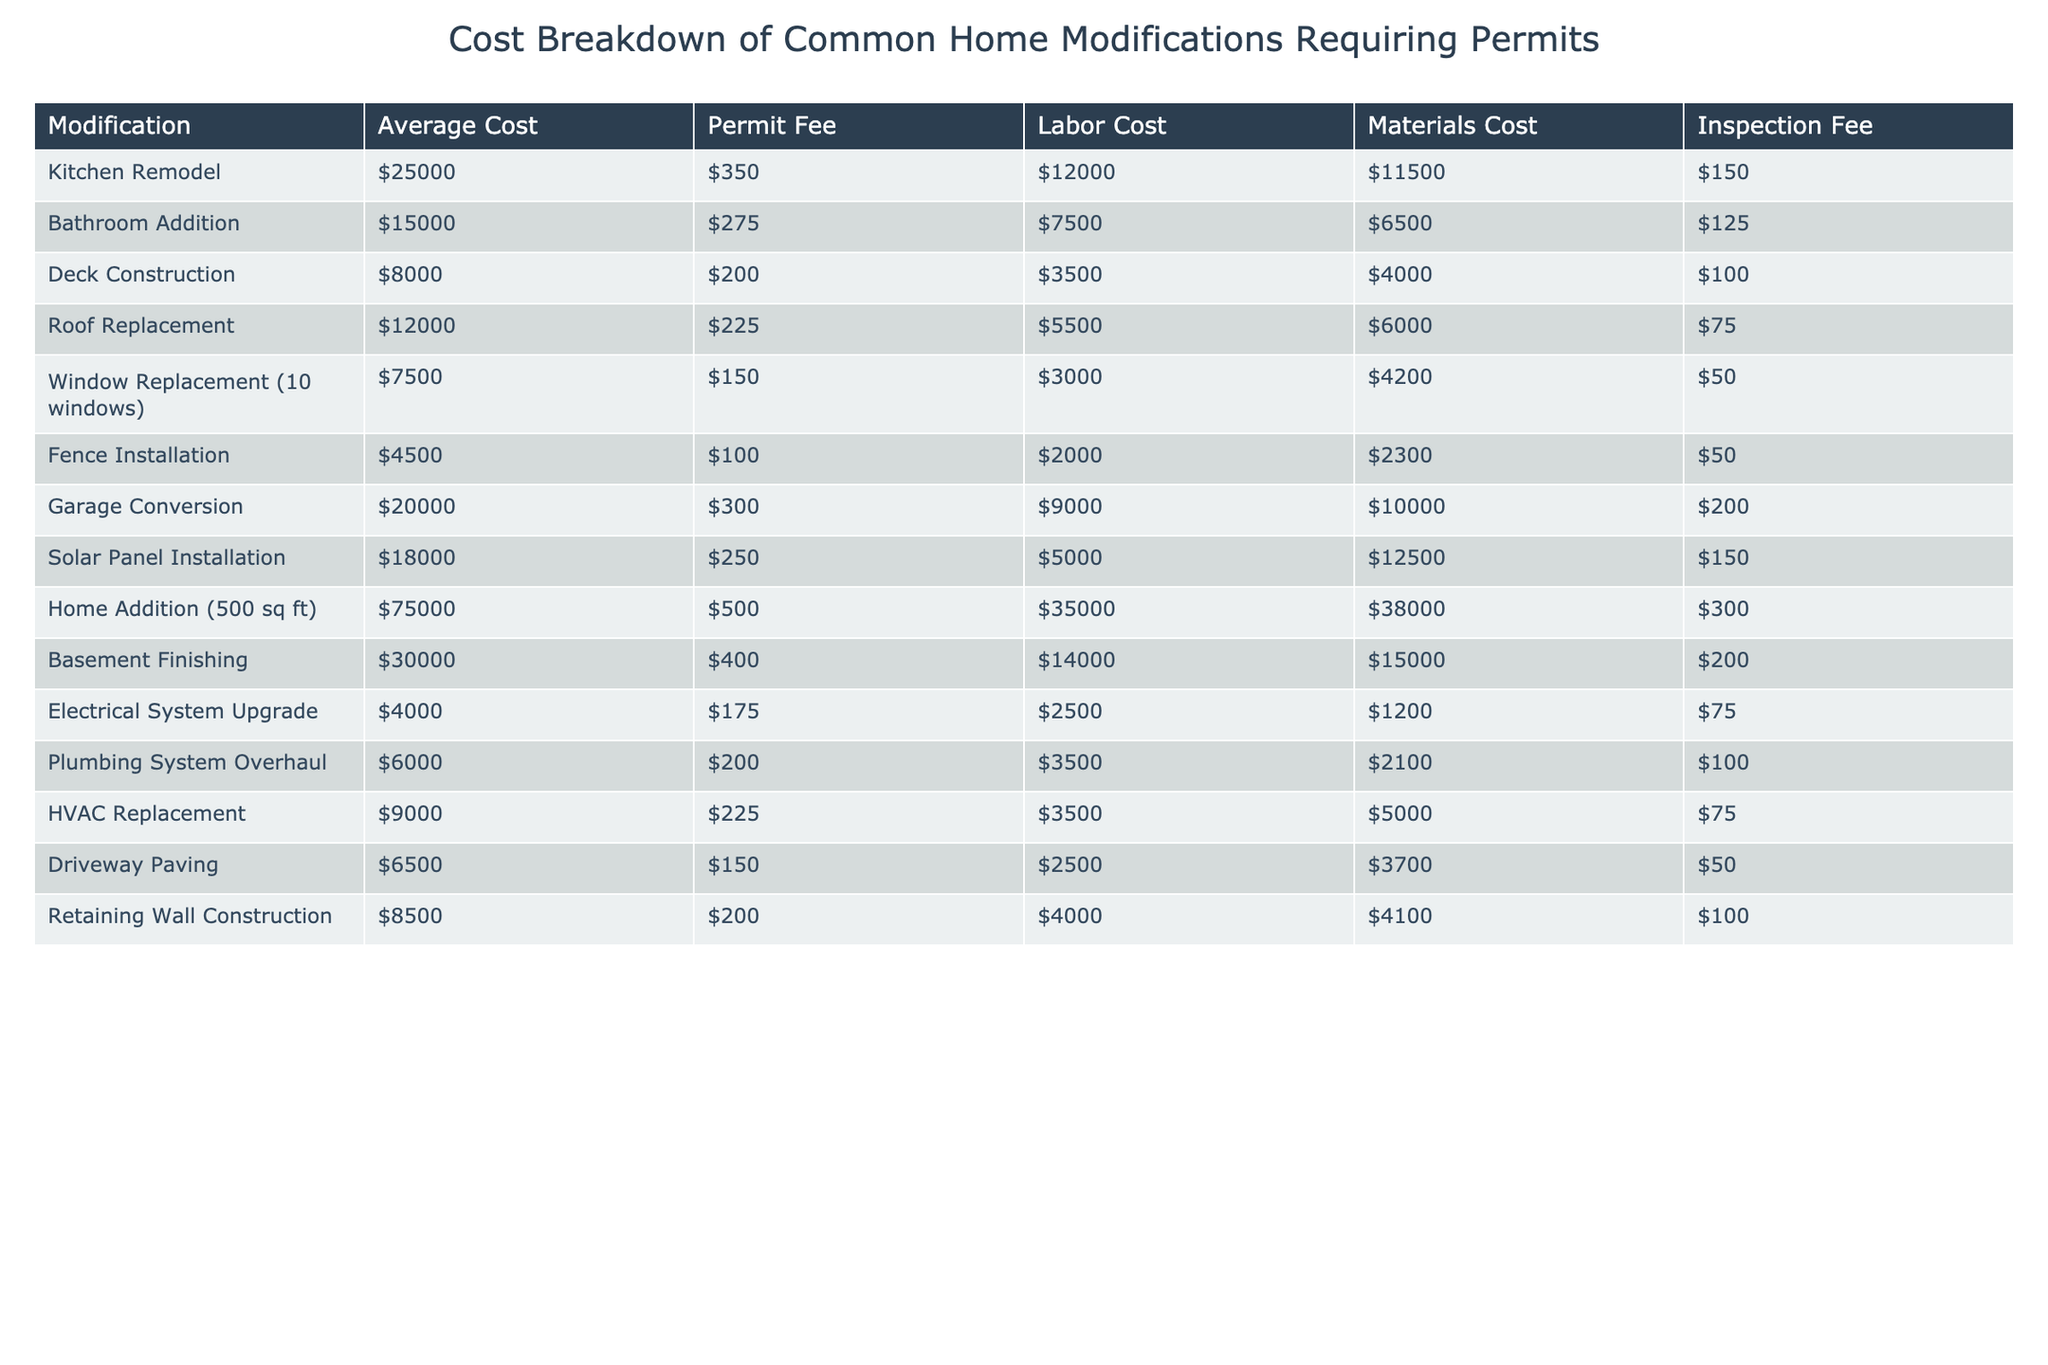What is the average cost of a kitchen remodel? The average cost for a kitchen remodel is listed directly in the table under "Average Cost," which shows $25,000.
Answer: $25,000 What is the highest permit fee for any modification? By scanning through the "Permit Fee" column, the highest fee is $500 for a home addition (500 sq ft).
Answer: $500 What is the total cost of a bathroom addition including all costs? For a bathroom addition, we add the average cost ($15,000), permit fee ($275), labor cost ($7,500), materials cost ($6,500), and inspection fee ($125). The total is $15,000 + $275 + $7,500 + $6,500 + $125 = $29,400.
Answer: $29,400 Does the solar panel installation cost more than a garage conversion? Comparing the average costs, solar panel installation is $18,000, while garage conversion is $20,000. Since $18,000 is not more than $20,000, the answer is no.
Answer: No What is the total labor cost for both a roof replacement and a fence installation? We find the labor costs for roof replacement ($5,500) and fence installation ($2,000) in the table. Adding these gives $5,500 + $2,000 = $7,500.
Answer: $7,500 Which modification has the highest average cost, and what is that cost? Scanning through the "Average Cost" column, the home addition (500 sq ft) has the highest cost of $75,000.
Answer: Home addition (500 sq ft), $75,000 If I decide to replace my windows in 10 units, what is the total cost including all fees? The total cost for window replacement includes the average cost ($7,500), permit fee ($150), labor cost ($3,000), materials cost ($4,200), and inspection fee ($50). Adding these gives $7,500 + $150 + $3,000 + $4,200 + $50 = $14,900.
Answer: $14,900 What is the difference in cost between a deck construction and HVAC replacement? The average costs are $8,000 for deck construction and $9,000 for HVAC replacement. The difference is calculated as $9,000 - $8,000 = $1,000.
Answer: $1,000 Is the inspection fee for the home addition less than the deck construction? The inspection fee for home addition is $300, while for deck construction it's $100. Since $300 is not less than $100, the answer is no.
Answer: No What's the total cost if I combine the costs of kitchen remodel and basement finishing? For the kitchen, the average cost is $25,000 and for basement finishing, it's $30,000. The total is $25,000 + $30,000 = $55,000.
Answer: $55,000 